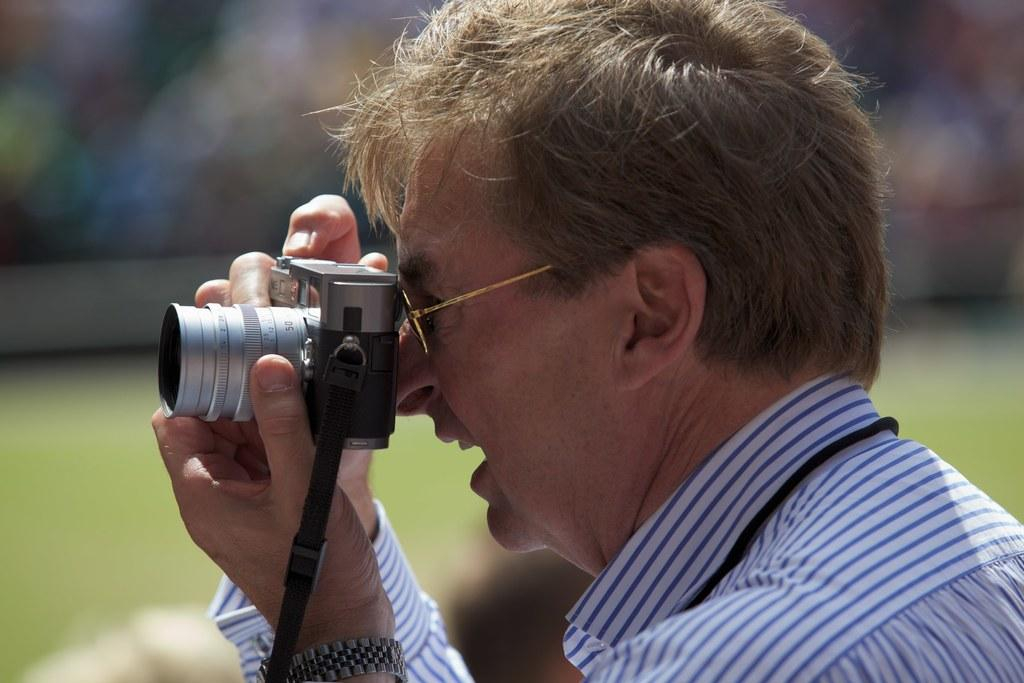What is the main subject of the image? There is a man in the image. What is the man holding in the image? The man is holding a camera with his hands. Can you describe the background of the image? The background of the image is blurred. What type of bait is the man using to catch fish in the image? There is no indication of fishing or bait in the image; the man is holding a camera. 